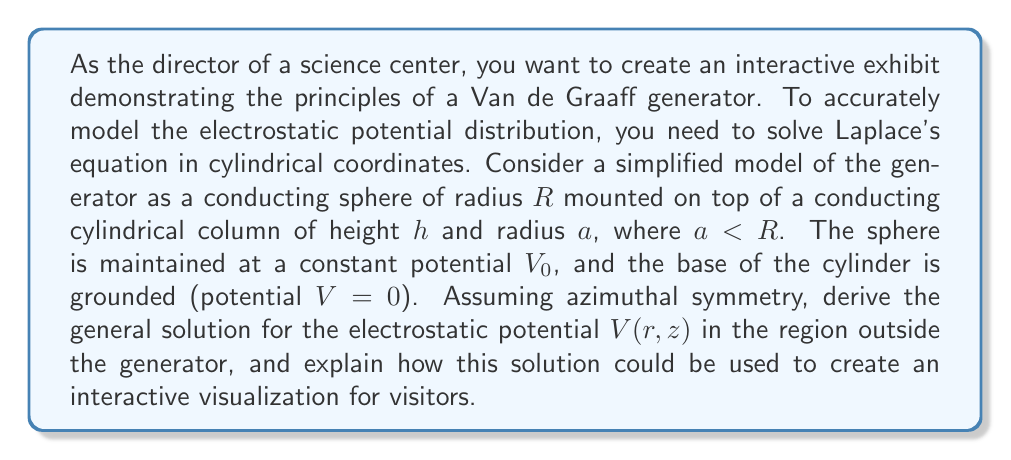Solve this math problem. To solve this problem, we'll follow these steps:

1) First, we need to write Laplace's equation in cylindrical coordinates with azimuthal symmetry:

   $$\frac{1}{r}\frac{\partial}{\partial r}\left(r\frac{\partial V}{\partial r}\right) + \frac{\partial^2 V}{\partial z^2} = 0$$

2) We can solve this equation using the method of separation of variables. Let $V(r,z) = R(r)Z(z)$. Substituting this into Laplace's equation and dividing by $RZ$, we get:

   $$\frac{1}{rR}\frac{d}{dr}\left(r\frac{dR}{dr}\right) + \frac{1}{Z}\frac{d^2Z}{dz^2} = 0$$

3) For this equation to be true for all $r$ and $z$, both terms must equal a constant. Let's call this constant $k^2$:

   $$\frac{1}{rR}\frac{d}{dr}\left(r\frac{dR}{dr}\right) = k^2$$
   $$\frac{1}{Z}\frac{d^2Z}{dz^2} = -k^2$$

4) The solution for $Z(z)$ is straightforward:
   
   $$Z(z) = A\sinh(kz) + B\cosh(kz)$$

5) The equation for $R(r)$ is a modified Bessel equation. Its general solution is:

   $$R(r) = CI_0(kr) + DK_0(kr)$$

   where $I_0$ and $K_0$ are modified Bessel functions of the first and second kind, respectively.

6) Therefore, the general solution for $V(r,z)$ is:

   $$V(r,z) = \int_0^\infty [A(k)\sinh(kz) + B(k)\cosh(kz)][C(k)I_0(kr) + D(k)K_0(kr)]dk$$

7) To determine the coefficients $A(k)$, $B(k)$, $C(k)$, and $D(k)$, we need to apply the boundary conditions:

   - $V(r,0) = 0$ for $r > a$ (grounded base)
   - $V(r,h) = V_0$ for $r < R$ (sphere at constant potential)
   - $V(r,z) \to 0$ as $r \to \infty$ (potential vanishes at large distances)

8) These conditions lead to $B(k) = 0$ and $C(k) = 0$. The remaining coefficients can be determined using Fourier-Bessel transforms, but the full derivation is beyond the scope of this explanation.

To create an interactive visualization, you could:

1) Use numerical methods to solve for the coefficients and plot equipotential surfaces.
2) Allow visitors to adjust parameters like $R$, $h$, $a$, and $V_0$ to see how they affect the potential distribution.
3) Use color gradients to represent potential strength, helping visitors understand the concept of electric field lines.
Answer: The general solution for the electrostatic potential $V(r,z)$ in the region outside the Van de Graaff generator is:

$$V(r,z) = \int_0^\infty A(k)\sinh(kz)K_0(kr)dk$$

where $A(k)$ is determined by the specific boundary conditions. This solution can be used to create an interactive visualization by numerically computing and plotting equipotential surfaces for various generator configurations. 